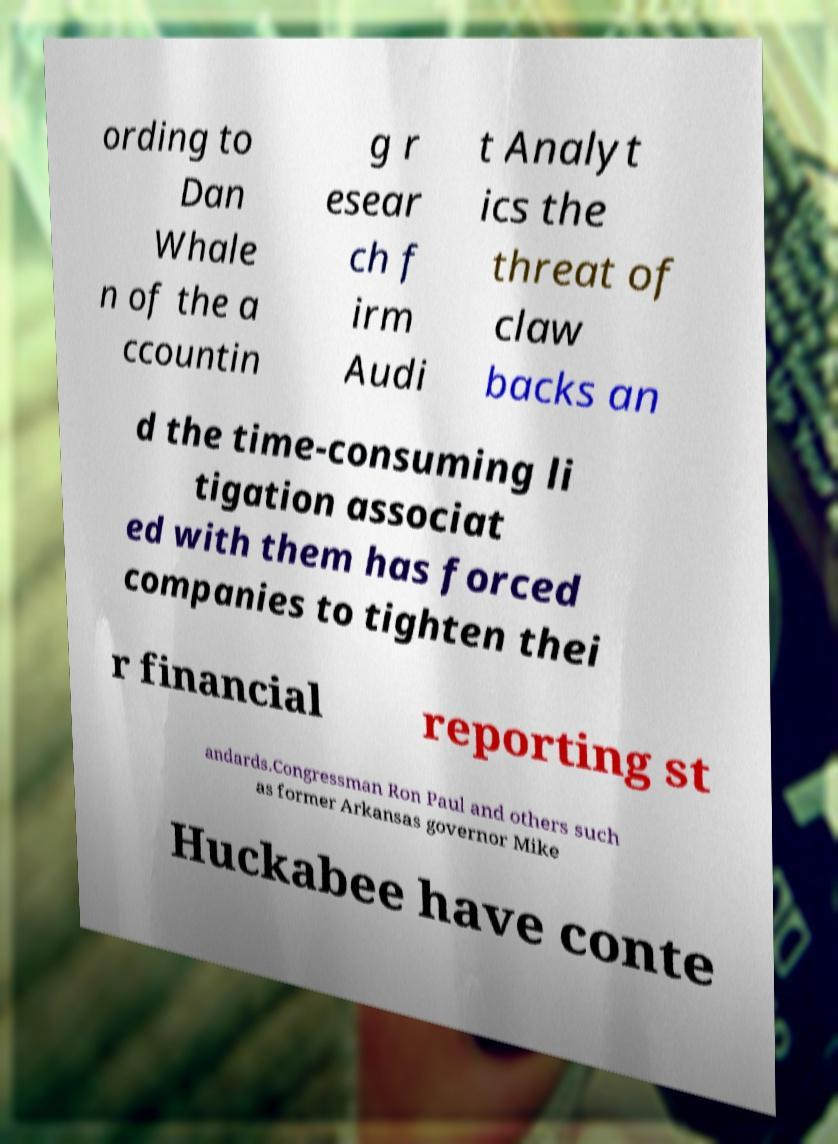Could you extract and type out the text from this image? ording to Dan Whale n of the a ccountin g r esear ch f irm Audi t Analyt ics the threat of claw backs an d the time-consuming li tigation associat ed with them has forced companies to tighten thei r financial reporting st andards.Congressman Ron Paul and others such as former Arkansas governor Mike Huckabee have conte 